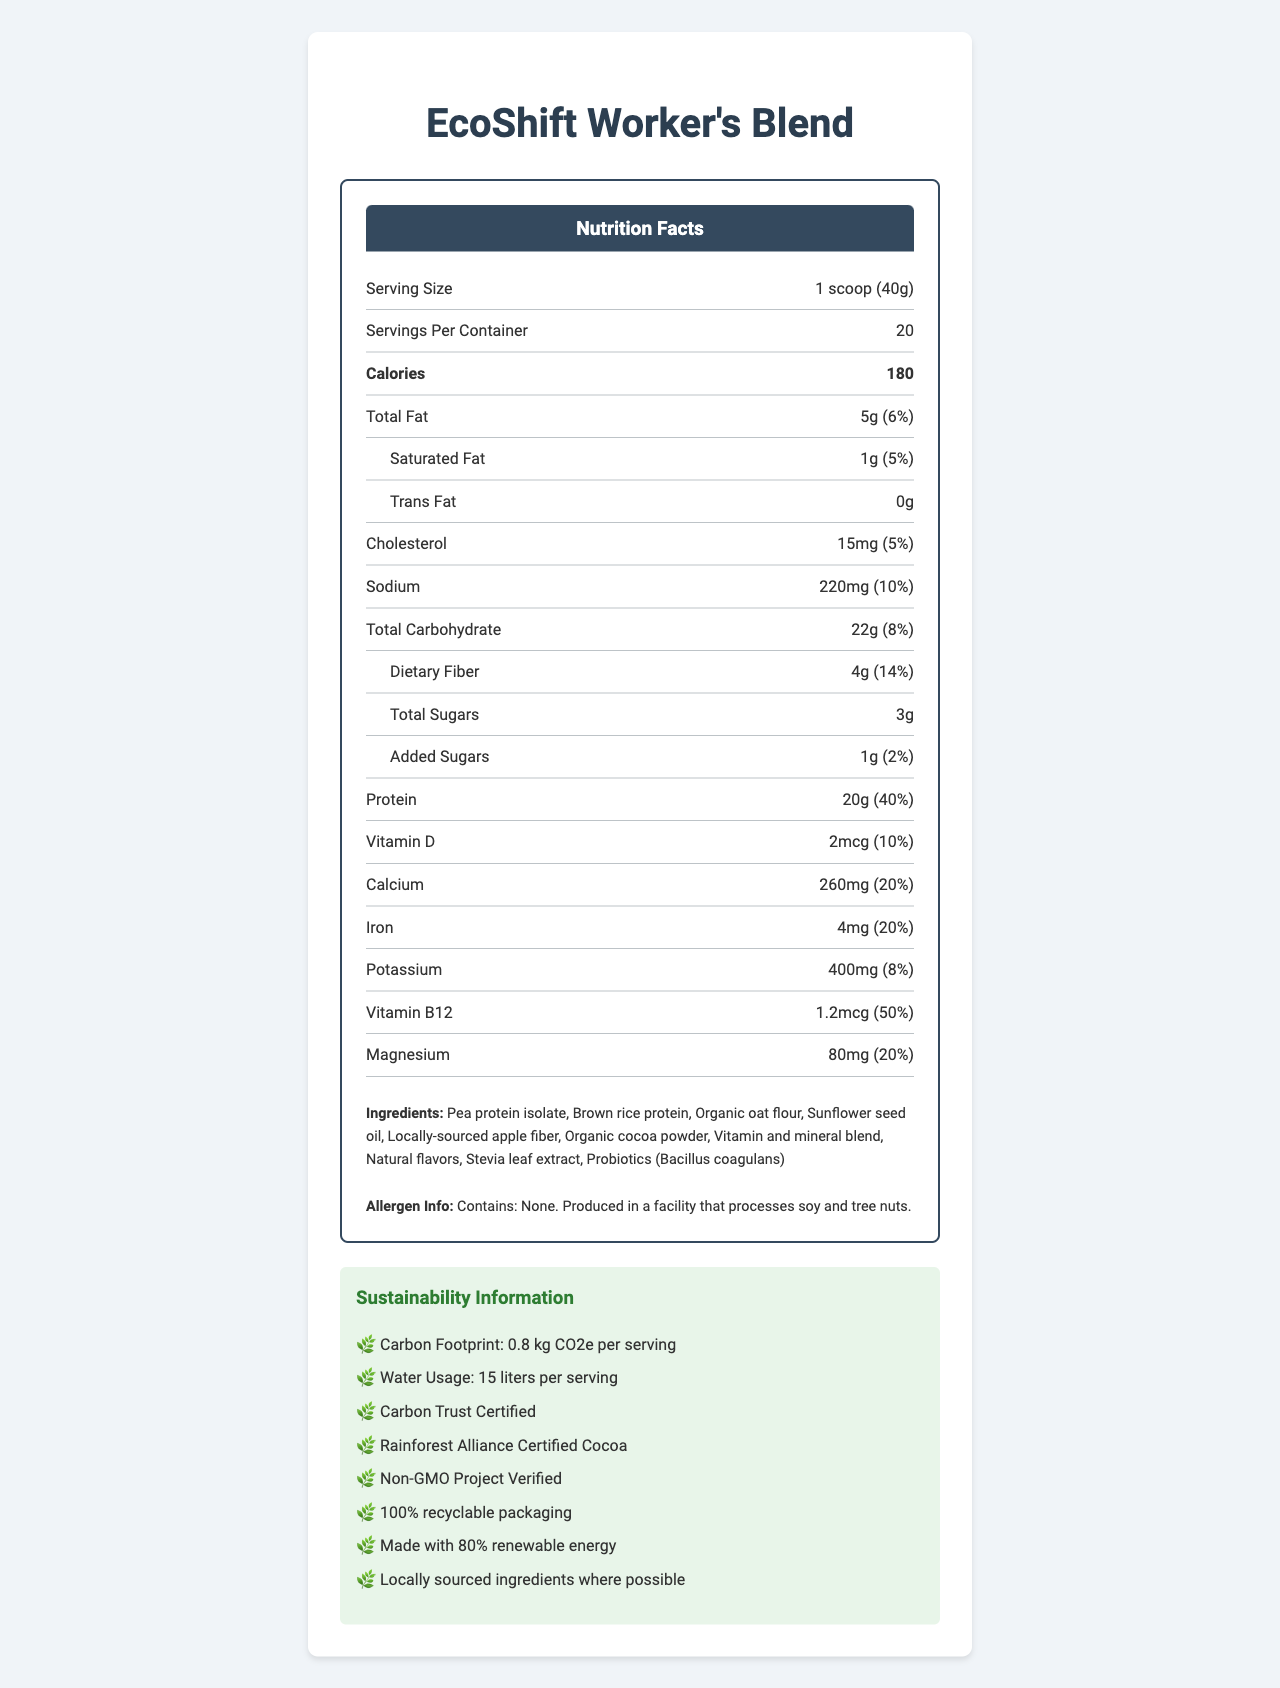What is the serving size of the EcoShift Worker's Blend? The document states the serving size as "1 scoop (40g)" near the top of the nutrition facts section.
Answer: 1 scoop (40g) How many servings are there per container? The number of servings per container is listed right below the serving size information, and it indicates 20 servings.
Answer: 20 How many calories are in one serving? The document specifies that each serving contains 180 calories.
Answer: 180 What is the total carbohydrate content per serving? The total carbohydrate content per serving is listed as "22g" in the nutrition facts section.
Answer: 22g What is the daily value percentage of protein per serving? The protein daily value percentage per serving is identified as 40% in the nutrition facts.
Answer: 40% What eco-certifications does the product have? A. Organic Certified B. Carbon Trust Certified C. Fair Trade Certified D. Non-GMO Project Verified The document mentions "Carbon Trust Certified" and "Non-GMO Project Verified" under eco-certifications.
Answer: B, D What is the amount of added sugars per serving? The document lists added sugars as "1g" in the nutrition facts.
Answer: 1g How much dietary fiber is in each serving? The amount of dietary fiber per serving is specified as 4g in the nutrition facts.
Answer: 4g What vitamins and minerals are included in significant amounts? A. Vitamin D B. Calcium C. Iron D. Vitamin B12 All the listed options (Vitamin D, Calcium, Iron, Vitamin B12) are mentioned in the nutrition facts with their respective percentages.
Answer: A, B, C, D Is this meal replacement shake suitable for people with nut allergies? The allergen information states that the product contains none but is produced in a facility that processes soy and tree nuts.
Answer: Yes Summarize the main idea of the document. The document describes the product as nutritious and sustainable, meant to support the health and productivity of factory workers, with details on its nutritional content, ingredients, allergen info, and eco-friendly features.
Answer: EcoShift Worker's Blend is a low-carbon footprint meal replacement shake designed for factory workers, focusing on nutrition, sustainability, and innovation. It contains high protein, essential vitamins, minerals, and fibers with a sustainable profile and eco-friendly certifications. How much water is used per serving of the product? The water usage per serving is listed as 15 liters in the sustainability information section.
Answer: 15 liters What percentage of daily value for magnesium is provided per serving? The daily value percentage for magnesium per serving is noted as 20%.
Answer: 20% What is the carbon footprint of one serving? The carbon footprint per serving is listed as "0.8 kg CO2e" in the sustainability information.
Answer: 0.8 kg CO2e What ingredients are used in the EcoShift Worker's Blend? The ingredients are enumerated in the document under the ingredients section.
Answer: Pea protein isolate, Brown rice protein, Organic oat flour, Sunflower seed oil, Locally-sourced apple fiber, Organic cocoa powder, Vitamin and mineral blend, Natural flavors, Stevia leaf extract, Probiotics (Bacillus coagulans) Does the product help with muscle recovery and hydration? The additional information specifies that the product supports muscle recovery and proper hydration.
Answer: Yes How many grams of trans fat are in each serving? The trans fat content is listed as 0g in the nutrition facts.
Answer: 0g Does the product contain any artificial sweeteners? The product contains Stevia leaf extract as a natural sweetener and does not list any artificial sweeteners in the ingredients.
Answer: No What type of energy is used to produce the product? The sustainability features mention that the product is made with 80% renewable energy.
Answer: 80% renewable energy What percentage of daily value for calcium is provided per serving? A. 10% B. 15% C. 20% D. 25% The calcium DV% per serving is listed as 20%.
Answer: C Where are the ingredients sourced from? The sustainability features note that ingredients are locally sourced where possible.
Answer: Locally, where possible Is the product's packaging recyclable? The sustainability features state that the packaging is 100% recyclable.
Answer: Yes What is the product name? The product name is given at the very top of the document.
Answer: EcoShift Worker's Blend What certifications does this product hold? The eco-certifications section lists these three certifications.
Answer: Carbon Trust Certified, Rainforest Alliance Certified Cocoa, Non-GMO Project Verified What is the primary source of protein in this meal replacement? The primary protein sources are listed as "Pea protein isolate" and "Brown rice protein" in the ingredients section.
Answer: Pea protein isolate and brown rice protein What is the low glycemic index benefit mentioned in the document? The additional information section mentions this benefit, indicating that the low glycemic index helps maintain stable blood sugar levels.
Answer: Stable blood sugar levels What do probiotics in the product do? The document does not provide specific details on the benefits of the probiotics (Bacillus coagulans) included in the product.
Answer: Cannot be determined 